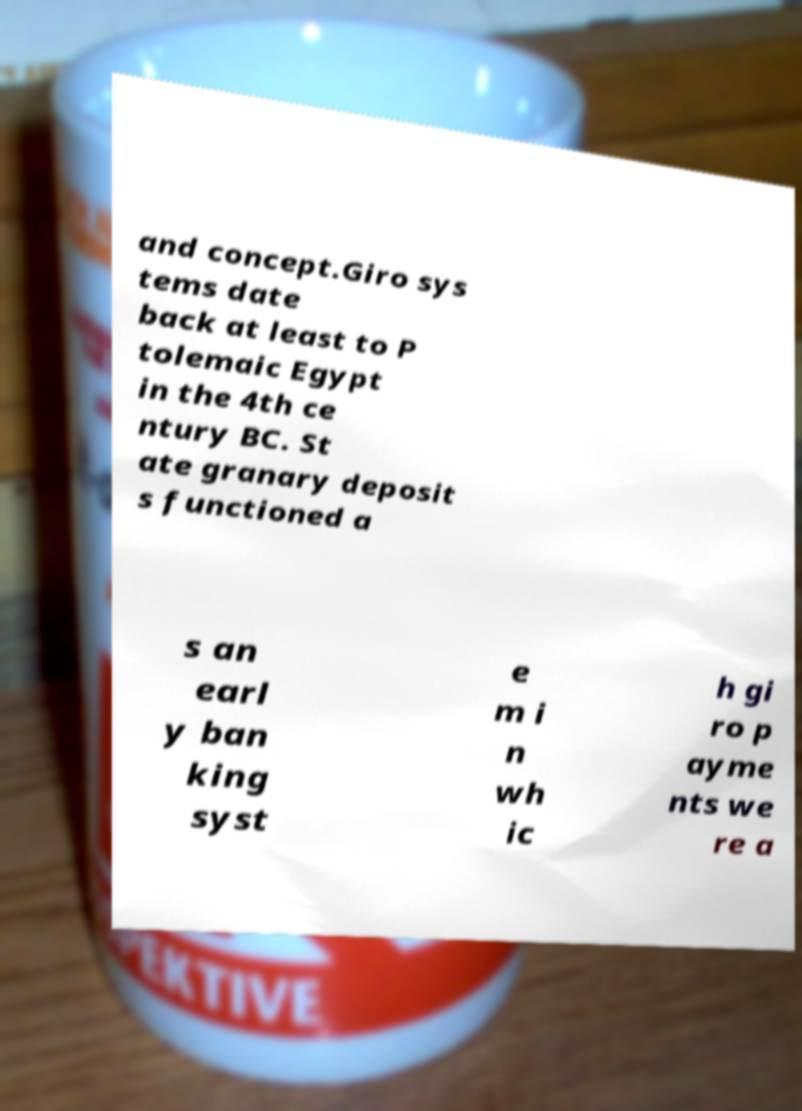Could you assist in decoding the text presented in this image and type it out clearly? and concept.Giro sys tems date back at least to P tolemaic Egypt in the 4th ce ntury BC. St ate granary deposit s functioned a s an earl y ban king syst e m i n wh ic h gi ro p ayme nts we re a 